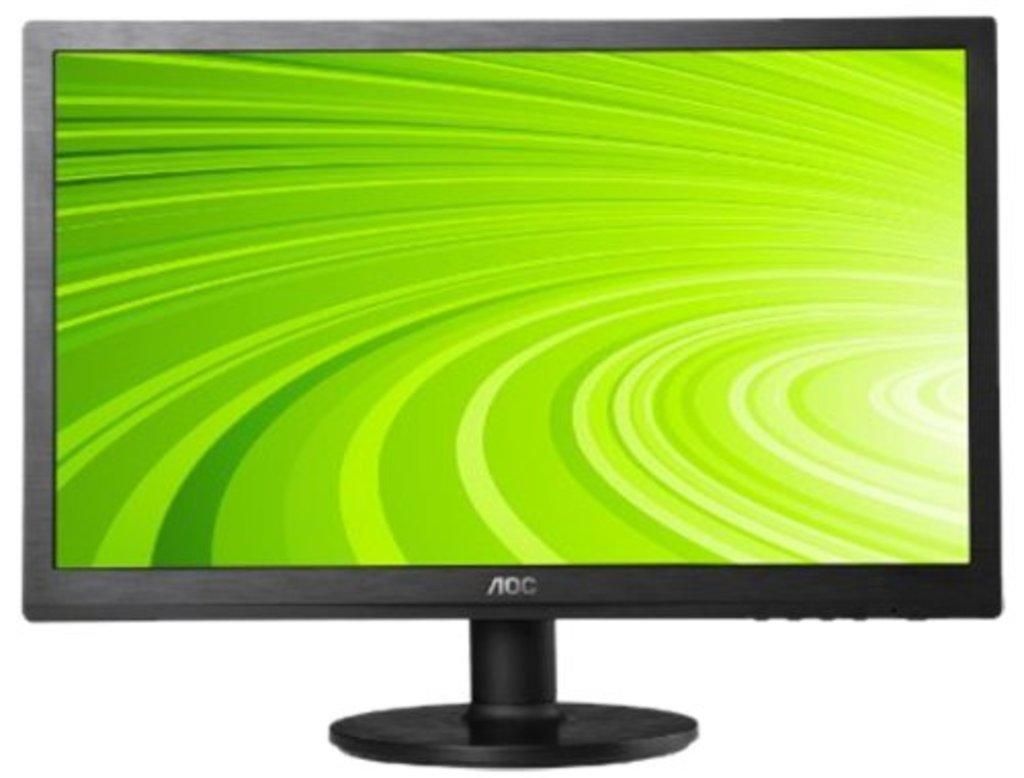What brand is this screen?
Your response must be concise. Aoc. 